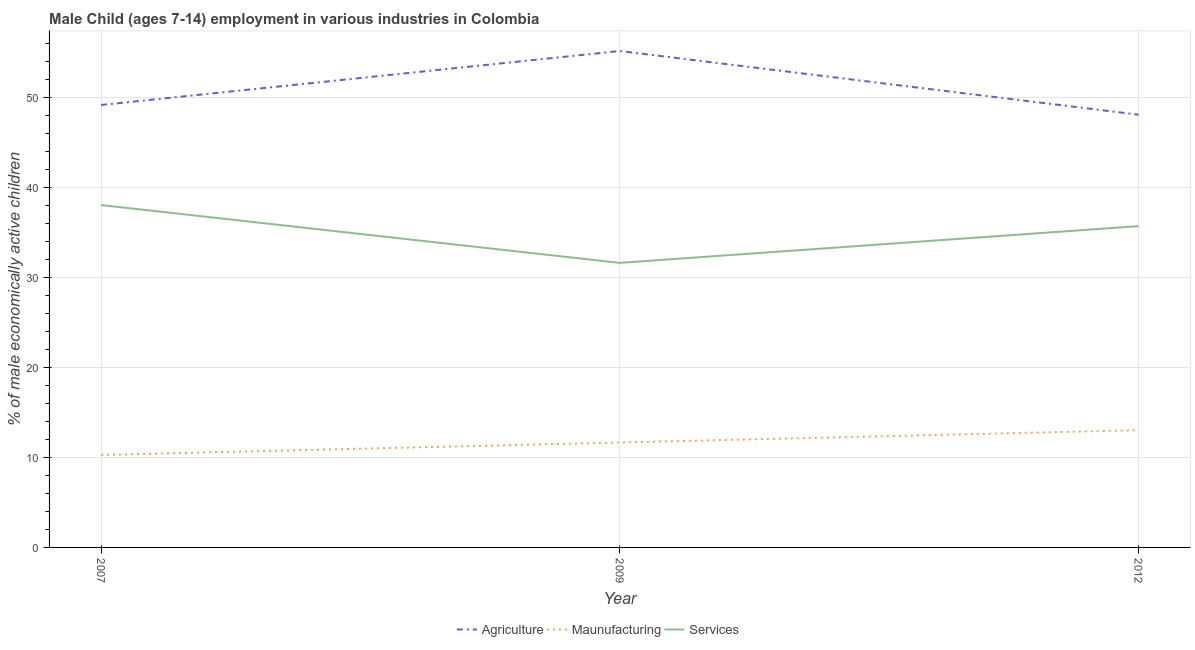Does the line corresponding to percentage of economically active children in manufacturing intersect with the line corresponding to percentage of economically active children in services?
Provide a succinct answer. No. What is the percentage of economically active children in manufacturing in 2007?
Make the answer very short. 10.27. Across all years, what is the maximum percentage of economically active children in agriculture?
Make the answer very short. 55.11. Across all years, what is the minimum percentage of economically active children in services?
Ensure brevity in your answer.  31.59. In which year was the percentage of economically active children in agriculture minimum?
Your answer should be very brief. 2012. What is the total percentage of economically active children in services in the graph?
Keep it short and to the point. 105.27. What is the difference between the percentage of economically active children in manufacturing in 2007 and that in 2012?
Give a very brief answer. -2.75. What is the difference between the percentage of economically active children in manufacturing in 2007 and the percentage of economically active children in services in 2012?
Your answer should be very brief. -25.4. What is the average percentage of economically active children in agriculture per year?
Ensure brevity in your answer.  50.76. In the year 2009, what is the difference between the percentage of economically active children in services and percentage of economically active children in agriculture?
Ensure brevity in your answer.  -23.52. In how many years, is the percentage of economically active children in agriculture greater than 26 %?
Give a very brief answer. 3. What is the ratio of the percentage of economically active children in manufacturing in 2007 to that in 2009?
Offer a very short reply. 0.88. Is the percentage of economically active children in agriculture in 2007 less than that in 2009?
Give a very brief answer. Yes. What is the difference between the highest and the second highest percentage of economically active children in manufacturing?
Provide a succinct answer. 1.37. What is the difference between the highest and the lowest percentage of economically active children in manufacturing?
Provide a short and direct response. 2.75. Is it the case that in every year, the sum of the percentage of economically active children in agriculture and percentage of economically active children in manufacturing is greater than the percentage of economically active children in services?
Your response must be concise. Yes. Does the percentage of economically active children in services monotonically increase over the years?
Keep it short and to the point. No. Is the percentage of economically active children in manufacturing strictly less than the percentage of economically active children in services over the years?
Your answer should be very brief. Yes. How many lines are there?
Your answer should be compact. 3. How many years are there in the graph?
Offer a very short reply. 3. What is the difference between two consecutive major ticks on the Y-axis?
Provide a short and direct response. 10. Are the values on the major ticks of Y-axis written in scientific E-notation?
Make the answer very short. No. Does the graph contain grids?
Your response must be concise. Yes. How many legend labels are there?
Ensure brevity in your answer.  3. What is the title of the graph?
Keep it short and to the point. Male Child (ages 7-14) employment in various industries in Colombia. Does "Errors" appear as one of the legend labels in the graph?
Offer a terse response. No. What is the label or title of the X-axis?
Give a very brief answer. Year. What is the label or title of the Y-axis?
Give a very brief answer. % of male economically active children. What is the % of male economically active children of Agriculture in 2007?
Ensure brevity in your answer.  49.12. What is the % of male economically active children in Maunufacturing in 2007?
Offer a terse response. 10.27. What is the % of male economically active children of Services in 2007?
Ensure brevity in your answer.  38.01. What is the % of male economically active children in Agriculture in 2009?
Ensure brevity in your answer.  55.11. What is the % of male economically active children in Maunufacturing in 2009?
Keep it short and to the point. 11.65. What is the % of male economically active children of Services in 2009?
Give a very brief answer. 31.59. What is the % of male economically active children in Agriculture in 2012?
Your response must be concise. 48.04. What is the % of male economically active children in Maunufacturing in 2012?
Offer a very short reply. 13.02. What is the % of male economically active children of Services in 2012?
Offer a terse response. 35.67. Across all years, what is the maximum % of male economically active children of Agriculture?
Your answer should be very brief. 55.11. Across all years, what is the maximum % of male economically active children in Maunufacturing?
Offer a very short reply. 13.02. Across all years, what is the maximum % of male economically active children in Services?
Keep it short and to the point. 38.01. Across all years, what is the minimum % of male economically active children in Agriculture?
Offer a very short reply. 48.04. Across all years, what is the minimum % of male economically active children of Maunufacturing?
Give a very brief answer. 10.27. Across all years, what is the minimum % of male economically active children of Services?
Your answer should be compact. 31.59. What is the total % of male economically active children of Agriculture in the graph?
Offer a very short reply. 152.27. What is the total % of male economically active children of Maunufacturing in the graph?
Ensure brevity in your answer.  34.94. What is the total % of male economically active children of Services in the graph?
Your answer should be very brief. 105.27. What is the difference between the % of male economically active children in Agriculture in 2007 and that in 2009?
Keep it short and to the point. -5.99. What is the difference between the % of male economically active children in Maunufacturing in 2007 and that in 2009?
Provide a short and direct response. -1.38. What is the difference between the % of male economically active children in Services in 2007 and that in 2009?
Ensure brevity in your answer.  6.42. What is the difference between the % of male economically active children in Agriculture in 2007 and that in 2012?
Ensure brevity in your answer.  1.08. What is the difference between the % of male economically active children in Maunufacturing in 2007 and that in 2012?
Your response must be concise. -2.75. What is the difference between the % of male economically active children in Services in 2007 and that in 2012?
Ensure brevity in your answer.  2.34. What is the difference between the % of male economically active children of Agriculture in 2009 and that in 2012?
Offer a terse response. 7.07. What is the difference between the % of male economically active children in Maunufacturing in 2009 and that in 2012?
Your response must be concise. -1.37. What is the difference between the % of male economically active children of Services in 2009 and that in 2012?
Your answer should be compact. -4.08. What is the difference between the % of male economically active children in Agriculture in 2007 and the % of male economically active children in Maunufacturing in 2009?
Offer a terse response. 37.47. What is the difference between the % of male economically active children of Agriculture in 2007 and the % of male economically active children of Services in 2009?
Your response must be concise. 17.53. What is the difference between the % of male economically active children in Maunufacturing in 2007 and the % of male economically active children in Services in 2009?
Ensure brevity in your answer.  -21.32. What is the difference between the % of male economically active children of Agriculture in 2007 and the % of male economically active children of Maunufacturing in 2012?
Provide a short and direct response. 36.1. What is the difference between the % of male economically active children of Agriculture in 2007 and the % of male economically active children of Services in 2012?
Your answer should be compact. 13.45. What is the difference between the % of male economically active children in Maunufacturing in 2007 and the % of male economically active children in Services in 2012?
Offer a terse response. -25.4. What is the difference between the % of male economically active children of Agriculture in 2009 and the % of male economically active children of Maunufacturing in 2012?
Offer a very short reply. 42.09. What is the difference between the % of male economically active children in Agriculture in 2009 and the % of male economically active children in Services in 2012?
Your response must be concise. 19.44. What is the difference between the % of male economically active children in Maunufacturing in 2009 and the % of male economically active children in Services in 2012?
Offer a very short reply. -24.02. What is the average % of male economically active children of Agriculture per year?
Keep it short and to the point. 50.76. What is the average % of male economically active children in Maunufacturing per year?
Provide a short and direct response. 11.65. What is the average % of male economically active children in Services per year?
Give a very brief answer. 35.09. In the year 2007, what is the difference between the % of male economically active children in Agriculture and % of male economically active children in Maunufacturing?
Ensure brevity in your answer.  38.85. In the year 2007, what is the difference between the % of male economically active children of Agriculture and % of male economically active children of Services?
Your answer should be very brief. 11.11. In the year 2007, what is the difference between the % of male economically active children in Maunufacturing and % of male economically active children in Services?
Ensure brevity in your answer.  -27.74. In the year 2009, what is the difference between the % of male economically active children of Agriculture and % of male economically active children of Maunufacturing?
Give a very brief answer. 43.46. In the year 2009, what is the difference between the % of male economically active children in Agriculture and % of male economically active children in Services?
Ensure brevity in your answer.  23.52. In the year 2009, what is the difference between the % of male economically active children in Maunufacturing and % of male economically active children in Services?
Offer a very short reply. -19.94. In the year 2012, what is the difference between the % of male economically active children of Agriculture and % of male economically active children of Maunufacturing?
Ensure brevity in your answer.  35.02. In the year 2012, what is the difference between the % of male economically active children in Agriculture and % of male economically active children in Services?
Keep it short and to the point. 12.37. In the year 2012, what is the difference between the % of male economically active children of Maunufacturing and % of male economically active children of Services?
Your response must be concise. -22.65. What is the ratio of the % of male economically active children in Agriculture in 2007 to that in 2009?
Provide a short and direct response. 0.89. What is the ratio of the % of male economically active children of Maunufacturing in 2007 to that in 2009?
Your response must be concise. 0.88. What is the ratio of the % of male economically active children in Services in 2007 to that in 2009?
Give a very brief answer. 1.2. What is the ratio of the % of male economically active children in Agriculture in 2007 to that in 2012?
Provide a succinct answer. 1.02. What is the ratio of the % of male economically active children of Maunufacturing in 2007 to that in 2012?
Your answer should be compact. 0.79. What is the ratio of the % of male economically active children in Services in 2007 to that in 2012?
Your answer should be compact. 1.07. What is the ratio of the % of male economically active children of Agriculture in 2009 to that in 2012?
Your answer should be compact. 1.15. What is the ratio of the % of male economically active children of Maunufacturing in 2009 to that in 2012?
Provide a short and direct response. 0.89. What is the ratio of the % of male economically active children in Services in 2009 to that in 2012?
Provide a succinct answer. 0.89. What is the difference between the highest and the second highest % of male economically active children of Agriculture?
Offer a very short reply. 5.99. What is the difference between the highest and the second highest % of male economically active children of Maunufacturing?
Your response must be concise. 1.37. What is the difference between the highest and the second highest % of male economically active children of Services?
Offer a terse response. 2.34. What is the difference between the highest and the lowest % of male economically active children in Agriculture?
Keep it short and to the point. 7.07. What is the difference between the highest and the lowest % of male economically active children in Maunufacturing?
Make the answer very short. 2.75. What is the difference between the highest and the lowest % of male economically active children of Services?
Your answer should be very brief. 6.42. 